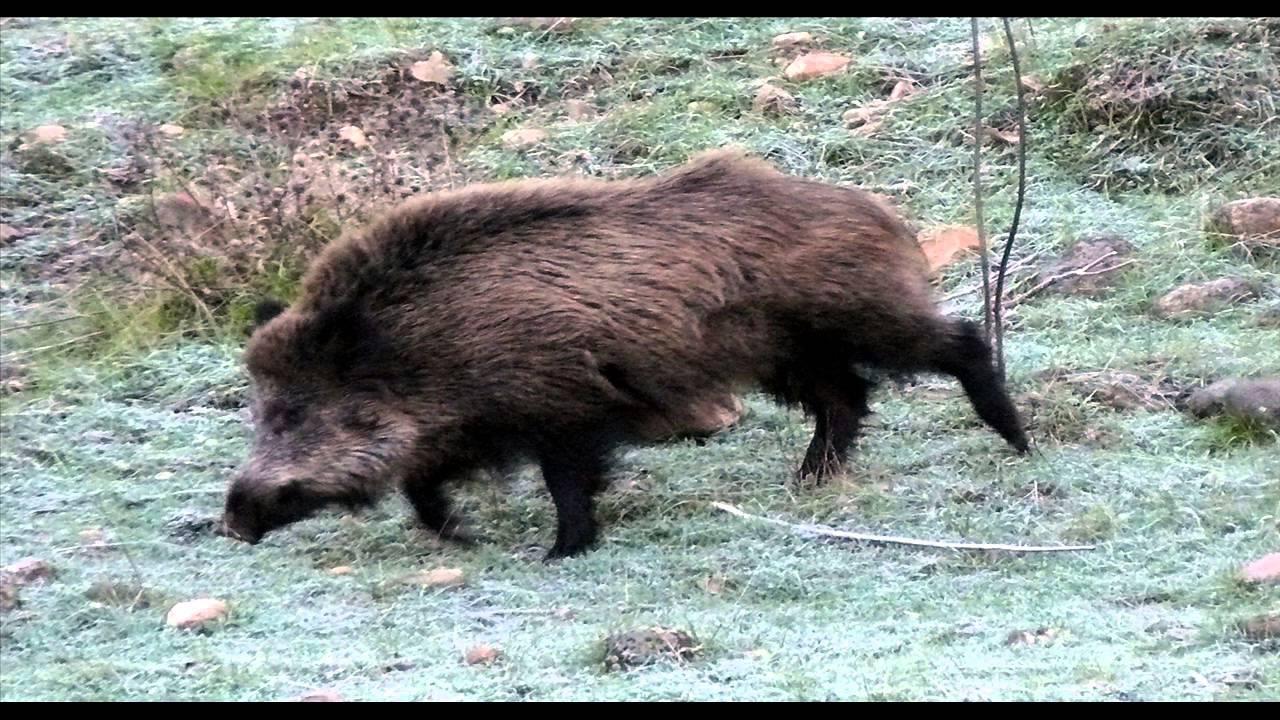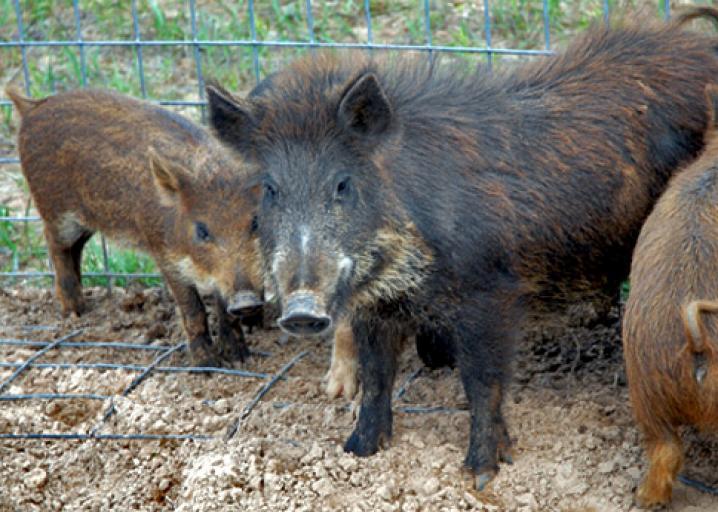The first image is the image on the left, the second image is the image on the right. Analyze the images presented: Is the assertion "An image shows only an adult boar, and no other animals." valid? Answer yes or no. Yes. 